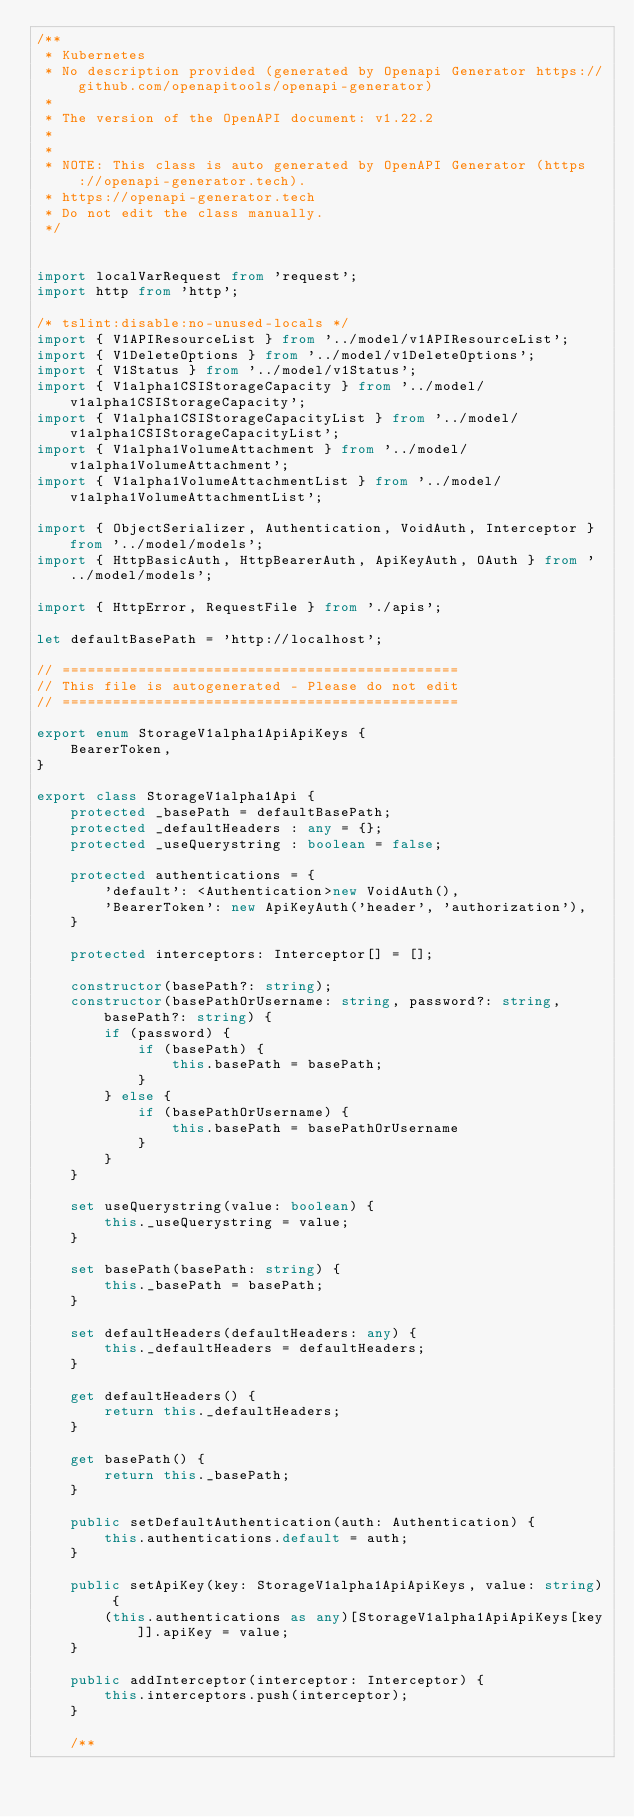<code> <loc_0><loc_0><loc_500><loc_500><_TypeScript_>/**
 * Kubernetes
 * No description provided (generated by Openapi Generator https://github.com/openapitools/openapi-generator)
 *
 * The version of the OpenAPI document: v1.22.2
 * 
 *
 * NOTE: This class is auto generated by OpenAPI Generator (https://openapi-generator.tech).
 * https://openapi-generator.tech
 * Do not edit the class manually.
 */


import localVarRequest from 'request';
import http from 'http';

/* tslint:disable:no-unused-locals */
import { V1APIResourceList } from '../model/v1APIResourceList';
import { V1DeleteOptions } from '../model/v1DeleteOptions';
import { V1Status } from '../model/v1Status';
import { V1alpha1CSIStorageCapacity } from '../model/v1alpha1CSIStorageCapacity';
import { V1alpha1CSIStorageCapacityList } from '../model/v1alpha1CSIStorageCapacityList';
import { V1alpha1VolumeAttachment } from '../model/v1alpha1VolumeAttachment';
import { V1alpha1VolumeAttachmentList } from '../model/v1alpha1VolumeAttachmentList';

import { ObjectSerializer, Authentication, VoidAuth, Interceptor } from '../model/models';
import { HttpBasicAuth, HttpBearerAuth, ApiKeyAuth, OAuth } from '../model/models';

import { HttpError, RequestFile } from './apis';

let defaultBasePath = 'http://localhost';

// ===============================================
// This file is autogenerated - Please do not edit
// ===============================================

export enum StorageV1alpha1ApiApiKeys {
    BearerToken,
}

export class StorageV1alpha1Api {
    protected _basePath = defaultBasePath;
    protected _defaultHeaders : any = {};
    protected _useQuerystring : boolean = false;

    protected authentications = {
        'default': <Authentication>new VoidAuth(),
        'BearerToken': new ApiKeyAuth('header', 'authorization'),
    }

    protected interceptors: Interceptor[] = [];

    constructor(basePath?: string);
    constructor(basePathOrUsername: string, password?: string, basePath?: string) {
        if (password) {
            if (basePath) {
                this.basePath = basePath;
            }
        } else {
            if (basePathOrUsername) {
                this.basePath = basePathOrUsername
            }
        }
    }

    set useQuerystring(value: boolean) {
        this._useQuerystring = value;
    }

    set basePath(basePath: string) {
        this._basePath = basePath;
    }

    set defaultHeaders(defaultHeaders: any) {
        this._defaultHeaders = defaultHeaders;
    }

    get defaultHeaders() {
        return this._defaultHeaders;
    }

    get basePath() {
        return this._basePath;
    }

    public setDefaultAuthentication(auth: Authentication) {
        this.authentications.default = auth;
    }

    public setApiKey(key: StorageV1alpha1ApiApiKeys, value: string) {
        (this.authentications as any)[StorageV1alpha1ApiApiKeys[key]].apiKey = value;
    }

    public addInterceptor(interceptor: Interceptor) {
        this.interceptors.push(interceptor);
    }

    /**</code> 